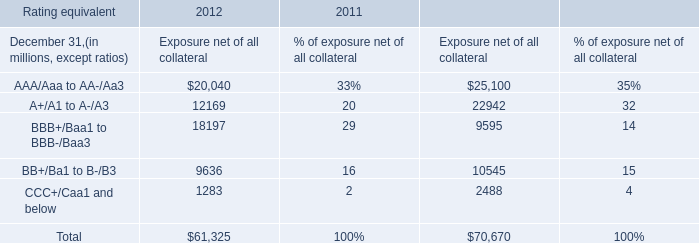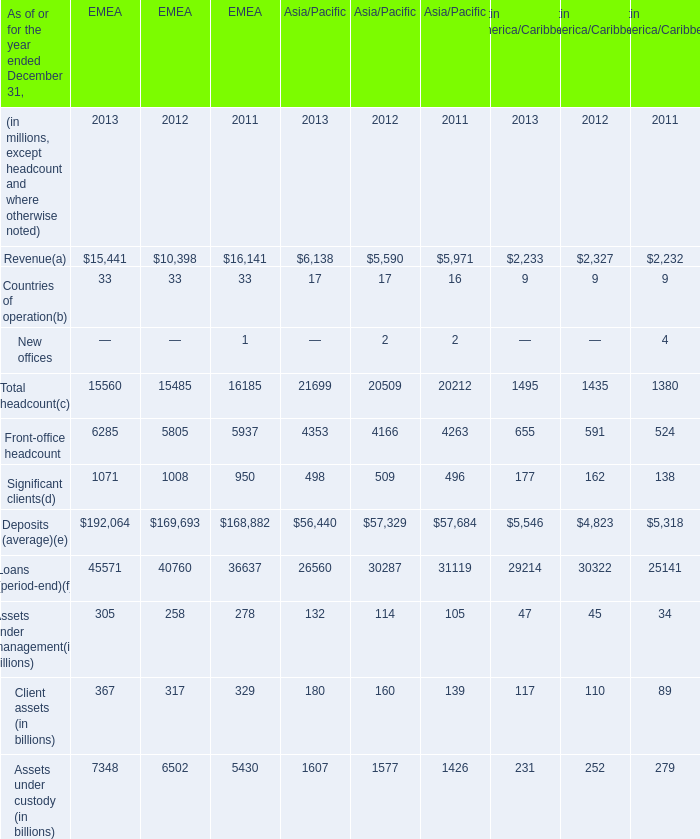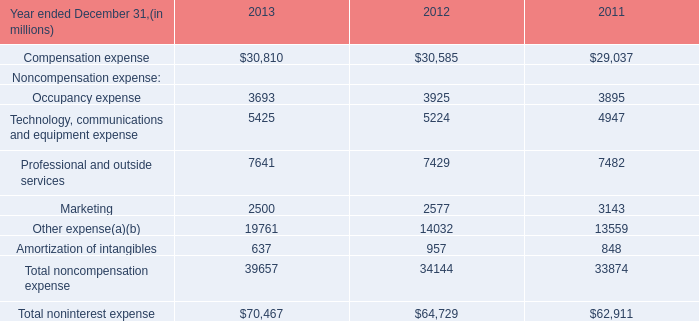What is the sum of Total headcount of EMEA in 2012 and Amortization of intangibles in 2013? (in million) 
Computations: (15485 + 637)
Answer: 16122.0. 